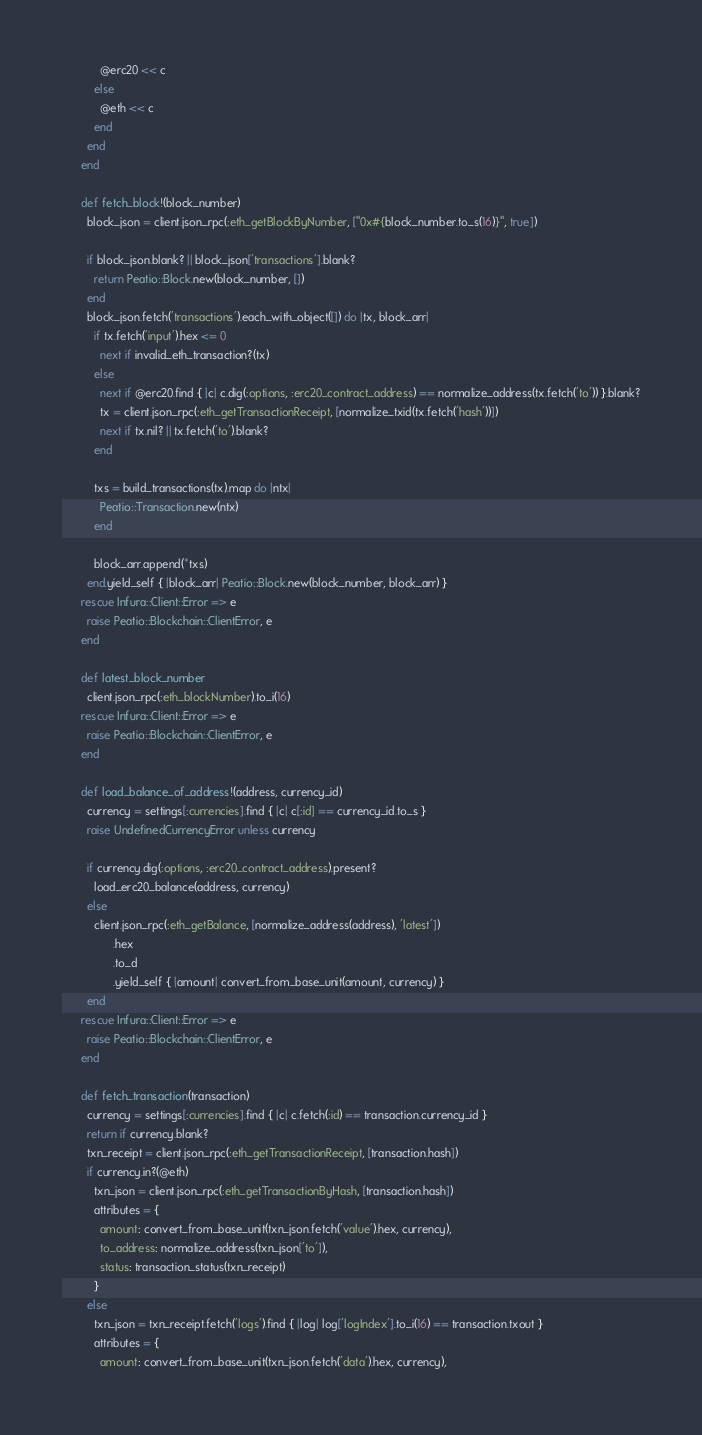<code> <loc_0><loc_0><loc_500><loc_500><_Ruby_>            @erc20 << c
          else
            @eth << c
          end
        end
      end

      def fetch_block!(block_number)
        block_json = client.json_rpc(:eth_getBlockByNumber, ["0x#{block_number.to_s(16)}", true])

        if block_json.blank? || block_json['transactions'].blank?
          return Peatio::Block.new(block_number, [])
        end
        block_json.fetch('transactions').each_with_object([]) do |tx, block_arr|
          if tx.fetch('input').hex <= 0
            next if invalid_eth_transaction?(tx)
          else
            next if @erc20.find { |c| c.dig(:options, :erc20_contract_address) == normalize_address(tx.fetch('to')) }.blank?
            tx = client.json_rpc(:eth_getTransactionReceipt, [normalize_txid(tx.fetch('hash'))])
            next if tx.nil? || tx.fetch('to').blank?
          end

          txs = build_transactions(tx).map do |ntx|
            Peatio::Transaction.new(ntx)
          end

          block_arr.append(*txs)
        end.yield_self { |block_arr| Peatio::Block.new(block_number, block_arr) }
      rescue Infura::Client::Error => e
        raise Peatio::Blockchain::ClientError, e
      end

      def latest_block_number
        client.json_rpc(:eth_blockNumber).to_i(16)
      rescue Infura::Client::Error => e
        raise Peatio::Blockchain::ClientError, e
      end

      def load_balance_of_address!(address, currency_id)
        currency = settings[:currencies].find { |c| c[:id] == currency_id.to_s }
        raise UndefinedCurrencyError unless currency

        if currency.dig(:options, :erc20_contract_address).present?
          load_erc20_balance(address, currency)
        else
          client.json_rpc(:eth_getBalance, [normalize_address(address), 'latest'])
                .hex
                .to_d
                .yield_self { |amount| convert_from_base_unit(amount, currency) }
        end
      rescue Infura::Client::Error => e
        raise Peatio::Blockchain::ClientError, e
      end

      def fetch_transaction(transaction)
        currency = settings[:currencies].find { |c| c.fetch(:id) == transaction.currency_id }
        return if currency.blank?
        txn_receipt = client.json_rpc(:eth_getTransactionReceipt, [transaction.hash])
        if currency.in?(@eth)
          txn_json = client.json_rpc(:eth_getTransactionByHash, [transaction.hash])
          attributes = {
            amount: convert_from_base_unit(txn_json.fetch('value').hex, currency),
            to_address: normalize_address(txn_json['to']),
            status: transaction_status(txn_receipt)
          }
        else
          txn_json = txn_receipt.fetch('logs').find { |log| log['logIndex'].to_i(16) == transaction.txout }
          attributes = {
            amount: convert_from_base_unit(txn_json.fetch('data').hex, currency),</code> 